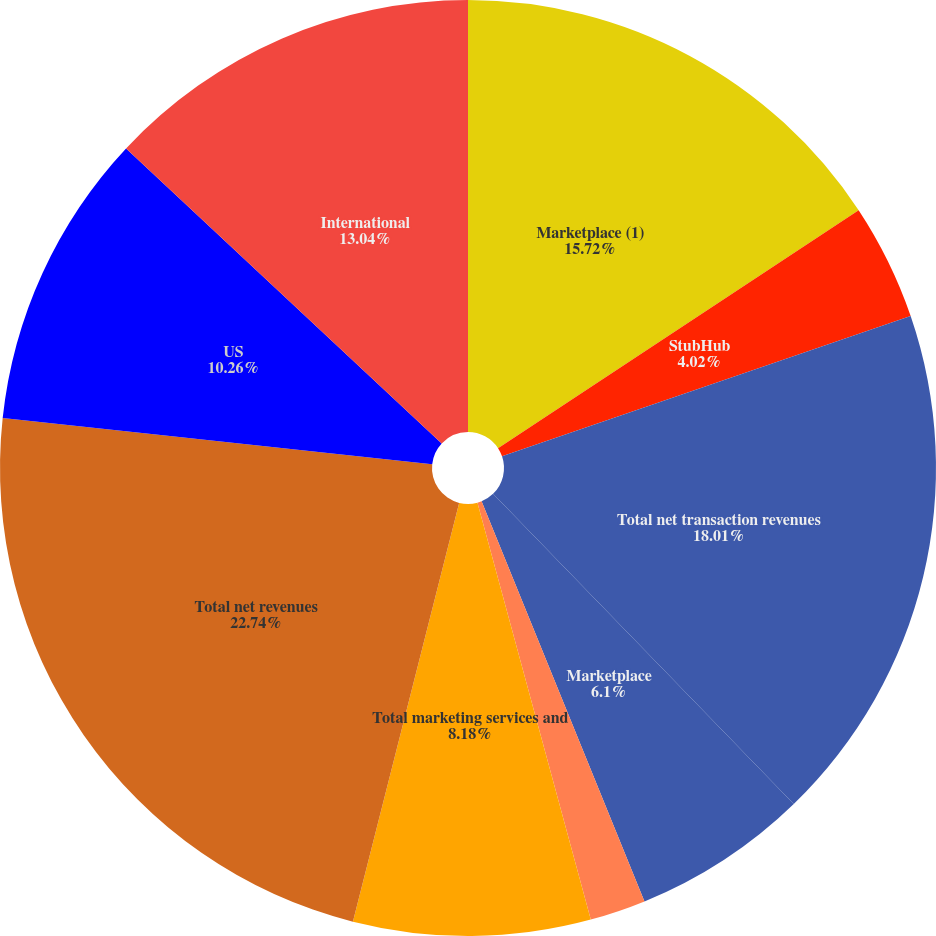<chart> <loc_0><loc_0><loc_500><loc_500><pie_chart><fcel>Marketplace (1)<fcel>StubHub<fcel>Total net transaction revenues<fcel>Marketplace<fcel>Classifieds<fcel>Total marketing services and<fcel>Total net revenues<fcel>US<fcel>International<nl><fcel>15.72%<fcel>4.02%<fcel>18.01%<fcel>6.1%<fcel>1.93%<fcel>8.18%<fcel>22.75%<fcel>10.26%<fcel>13.04%<nl></chart> 